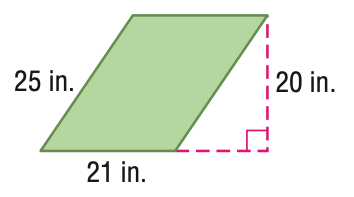Answer the mathemtical geometry problem and directly provide the correct option letter.
Question: Find the area of the parallelogram. Round to the nearest tenth if necessary.
Choices: A: 92 B: 210 C: 420 D: 525 C 